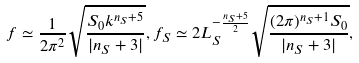Convert formula to latex. <formula><loc_0><loc_0><loc_500><loc_500>f \simeq \frac { 1 } { 2 \pi ^ { 2 } } \sqrt { \frac { S _ { 0 } k ^ { n _ { S } + 5 } } { | n _ { S } + 3 | } } , f _ { S } \simeq 2 L _ { S } ^ { - \frac { n _ { S } + 5 } { 2 } } \sqrt { \frac { ( 2 \pi ) ^ { n _ { S } + 1 } S _ { 0 } } { | n _ { S } + 3 | } } ,</formula> 